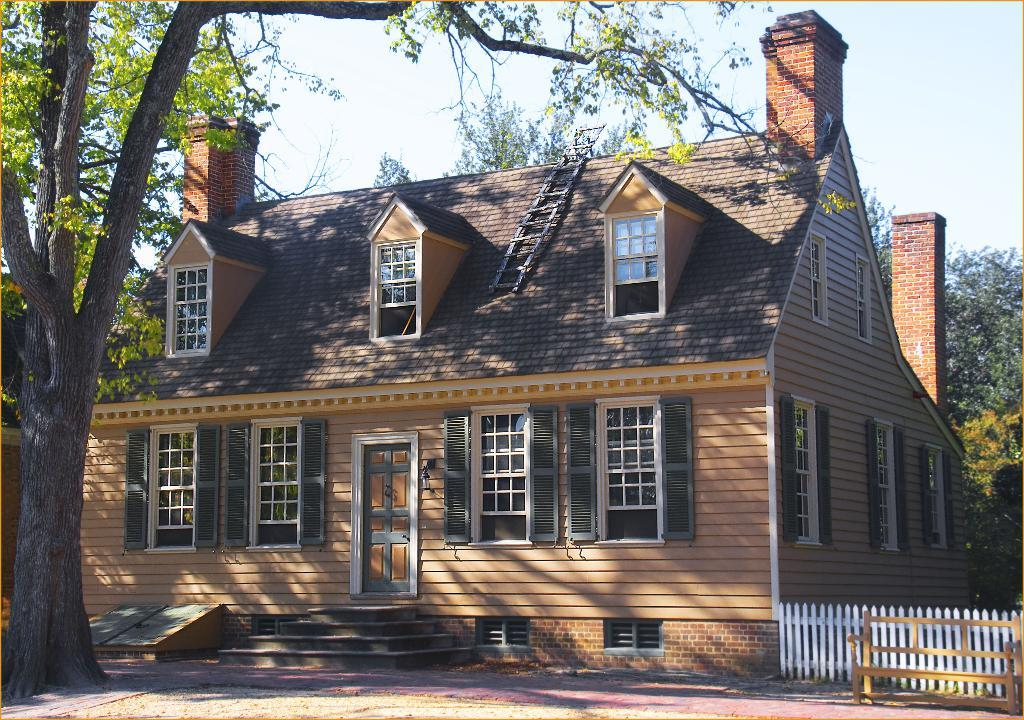What type of house is in the image? There is a wooden house in the image. What is on the roof of the house? There is a ladder on the roof of the house. What architectural feature is present in the image? There are steps in the image. What is the primary mode of transportation in the image? There is a road in the image, which suggests that vehicles might be used for transportation. What type of barrier is present in the image? There is a wooden fence in the image. What type of seating is present in the image? There is a wooden bench in the image. What can be seen in the background of the image? There are trees and the sky visible in the background of the image. What type of pie is being served on the wooden bench in the image? There is no pie present in the image; it features a wooden house with a ladder on the roof, steps, a wooden fence, and a wooden bench. What type of lock is securing the ladder on the roof of the house in the image? There is no lock present on the ladder in the image; it is simply resting on the roof of the house. 